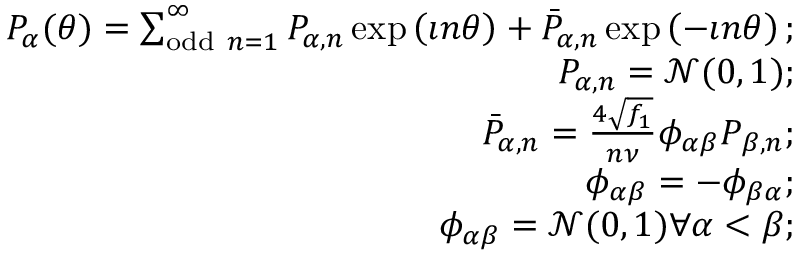<formula> <loc_0><loc_0><loc_500><loc_500>\begin{array} { r l r } & { P _ { \alpha } ( \theta ) = \sum _ { o d d n = 1 } ^ { \infty } P _ { \alpha , n } \exp \left ( \imath n \theta \right ) + \bar { P } _ { \alpha , n } \exp \left ( - \imath n \theta \right ) ; } \\ & { P _ { \alpha , n } = \mathcal { N } ( 0 , 1 ) ; } \\ & { \bar { P } _ { \alpha , n } = \frac { 4 \sqrt { f _ { 1 } } } { n \nu } \phi _ { \alpha \beta } P _ { \beta , n } ; } \\ & { \phi _ { \alpha \beta } = - \phi _ { \beta \alpha } ; } \\ & { \phi _ { \alpha \beta } = \mathcal { N } ( 0 , 1 ) \forall \alpha < \beta ; } \end{array}</formula> 